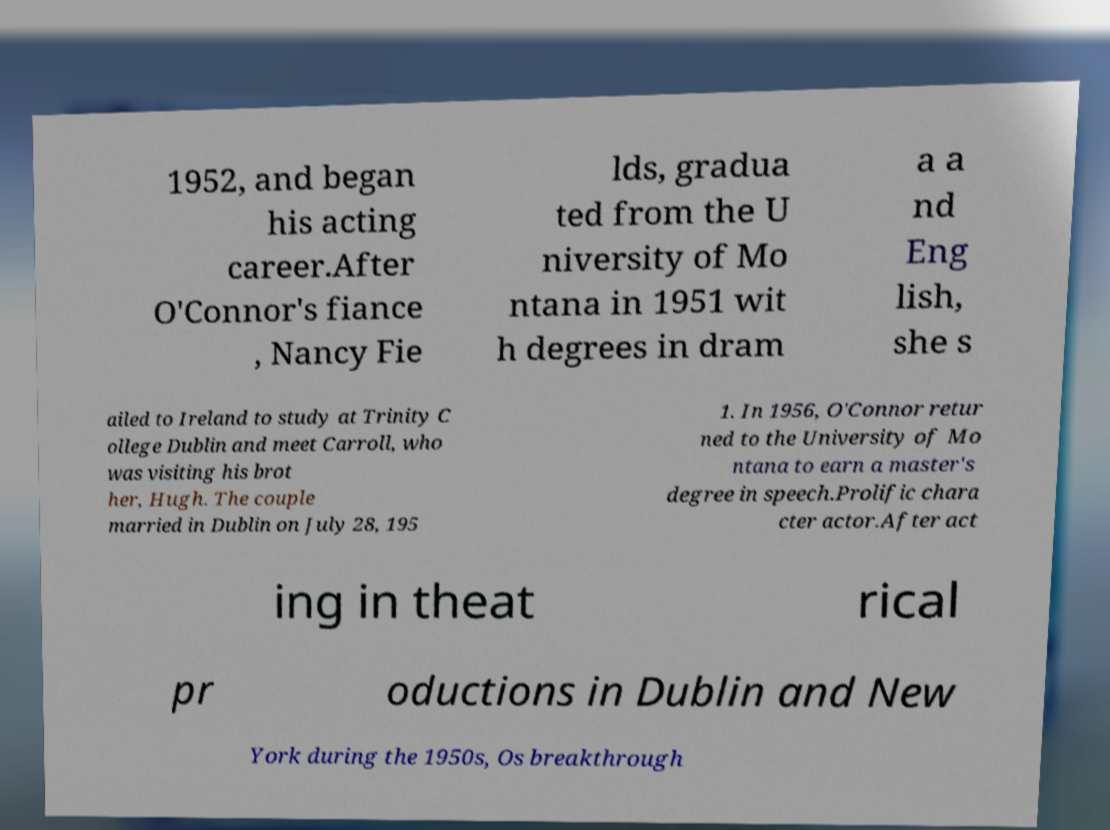Can you read and provide the text displayed in the image?This photo seems to have some interesting text. Can you extract and type it out for me? 1952, and began his acting career.After O'Connor's fiance , Nancy Fie lds, gradua ted from the U niversity of Mo ntana in 1951 wit h degrees in dram a a nd Eng lish, she s ailed to Ireland to study at Trinity C ollege Dublin and meet Carroll, who was visiting his brot her, Hugh. The couple married in Dublin on July 28, 195 1. In 1956, O'Connor retur ned to the University of Mo ntana to earn a master's degree in speech.Prolific chara cter actor.After act ing in theat rical pr oductions in Dublin and New York during the 1950s, Os breakthrough 